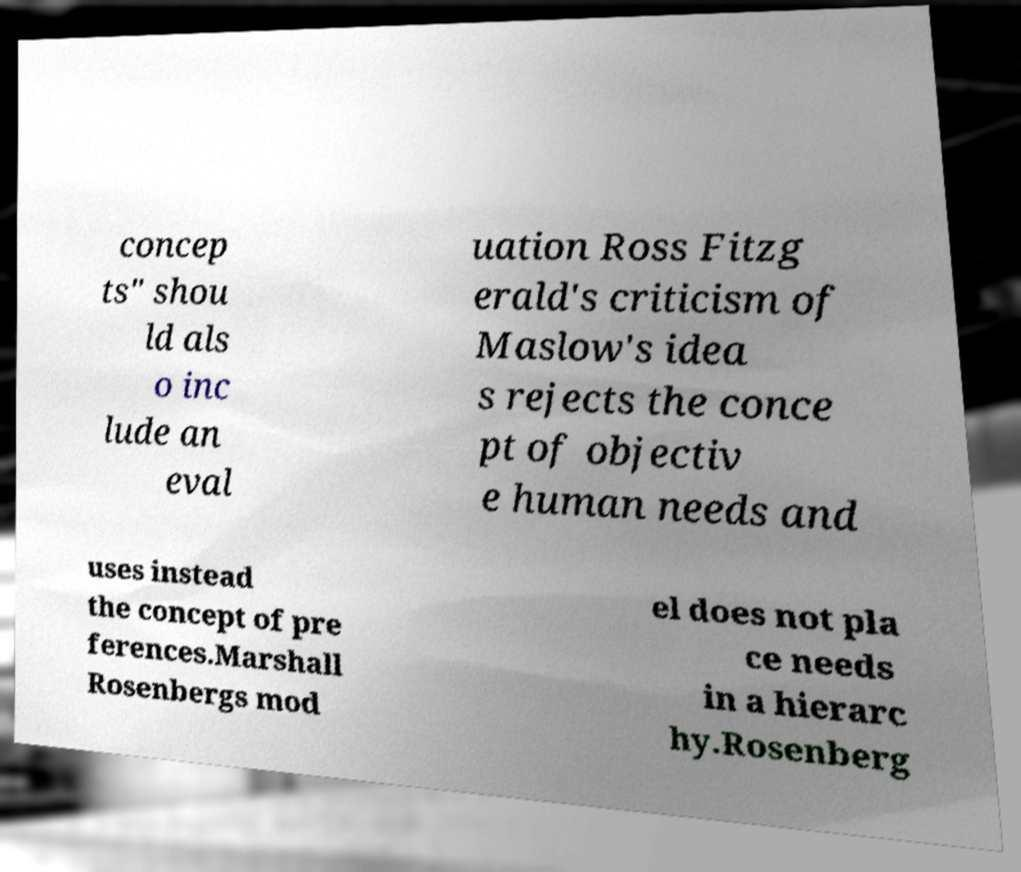What messages or text are displayed in this image? I need them in a readable, typed format. concep ts" shou ld als o inc lude an eval uation Ross Fitzg erald's criticism of Maslow's idea s rejects the conce pt of objectiv e human needs and uses instead the concept of pre ferences.Marshall Rosenbergs mod el does not pla ce needs in a hierarc hy.Rosenberg 